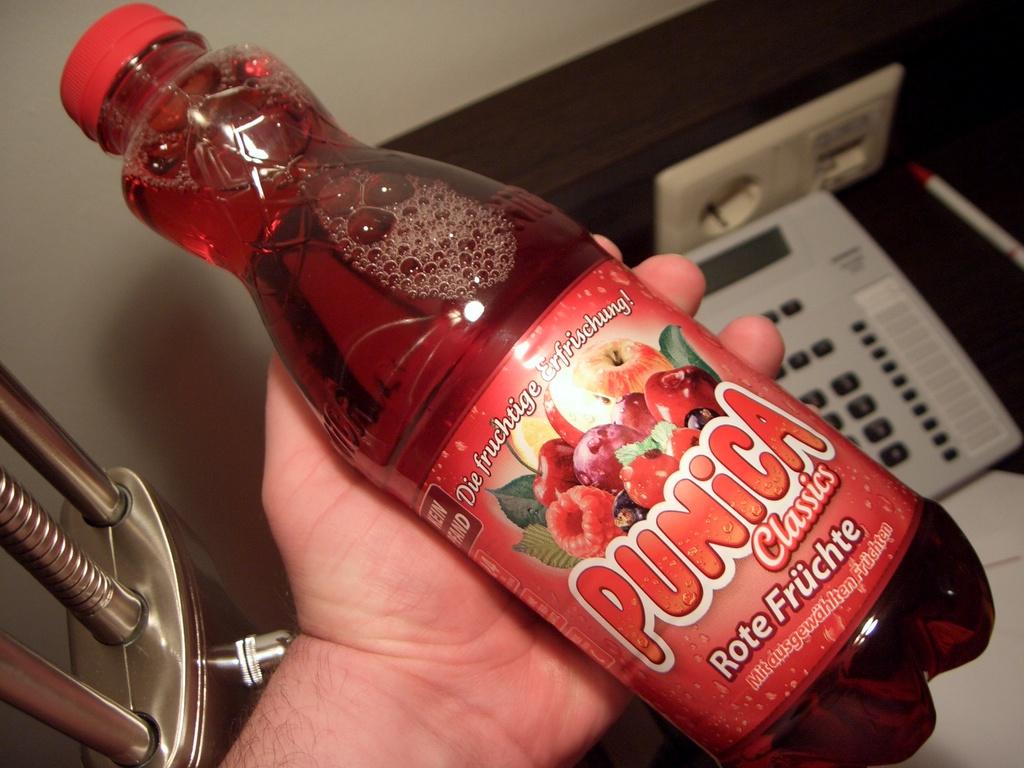Who makes this classic fruit drink?
Give a very brief answer. Punica. 